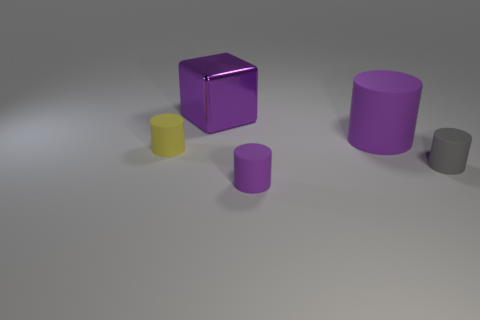Are there any other things that are the same material as the big purple cube?
Ensure brevity in your answer.  No. There is a big matte thing that is the same color as the shiny object; what shape is it?
Offer a terse response. Cylinder. There is a cube that is the same color as the big rubber cylinder; what size is it?
Offer a terse response. Large. How many large cylinders have the same color as the metal cube?
Provide a short and direct response. 1. There is a big matte thing; does it have the same color as the small matte cylinder in front of the small gray object?
Give a very brief answer. Yes. There is a purple thing that is to the left of the big purple matte object and behind the small purple thing; what is its shape?
Your response must be concise. Cube. The purple cylinder that is behind the gray rubber object that is in front of the matte cylinder on the left side of the tiny purple rubber cylinder is made of what material?
Give a very brief answer. Rubber. Is the number of cylinders that are in front of the small gray thing greater than the number of metal blocks on the right side of the large cylinder?
Make the answer very short. Yes. What number of large purple cylinders are made of the same material as the small purple object?
Provide a succinct answer. 1. There is a large purple object behind the large matte cylinder; is it the same shape as the big purple object that is in front of the purple metal block?
Provide a short and direct response. No. 